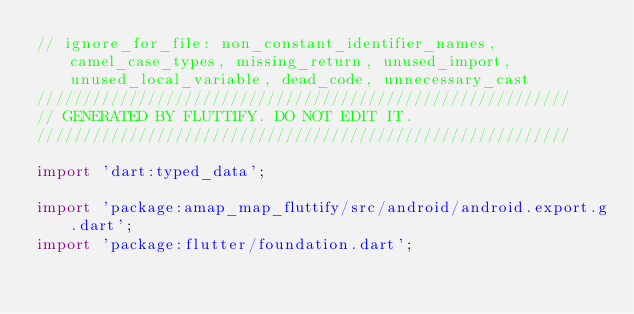<code> <loc_0><loc_0><loc_500><loc_500><_Dart_>// ignore_for_file: non_constant_identifier_names, camel_case_types, missing_return, unused_import, unused_local_variable, dead_code, unnecessary_cast
//////////////////////////////////////////////////////////
// GENERATED BY FLUTTIFY. DO NOT EDIT IT.
//////////////////////////////////////////////////////////

import 'dart:typed_data';

import 'package:amap_map_fluttify/src/android/android.export.g.dart';
import 'package:flutter/foundation.dart';</code> 